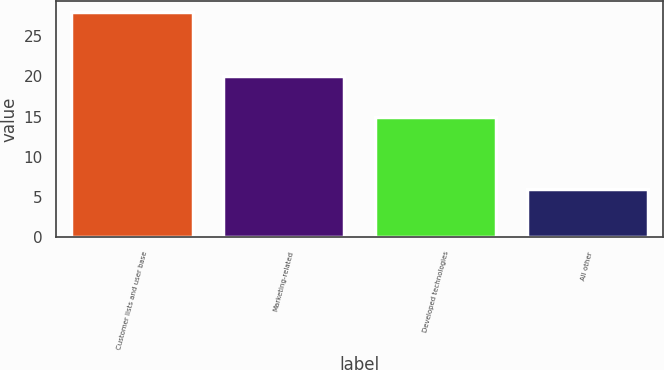Convert chart to OTSL. <chart><loc_0><loc_0><loc_500><loc_500><bar_chart><fcel>Customer lists and user base<fcel>Marketing-related<fcel>Developed technologies<fcel>All other<nl><fcel>28<fcel>20<fcel>15<fcel>6<nl></chart> 